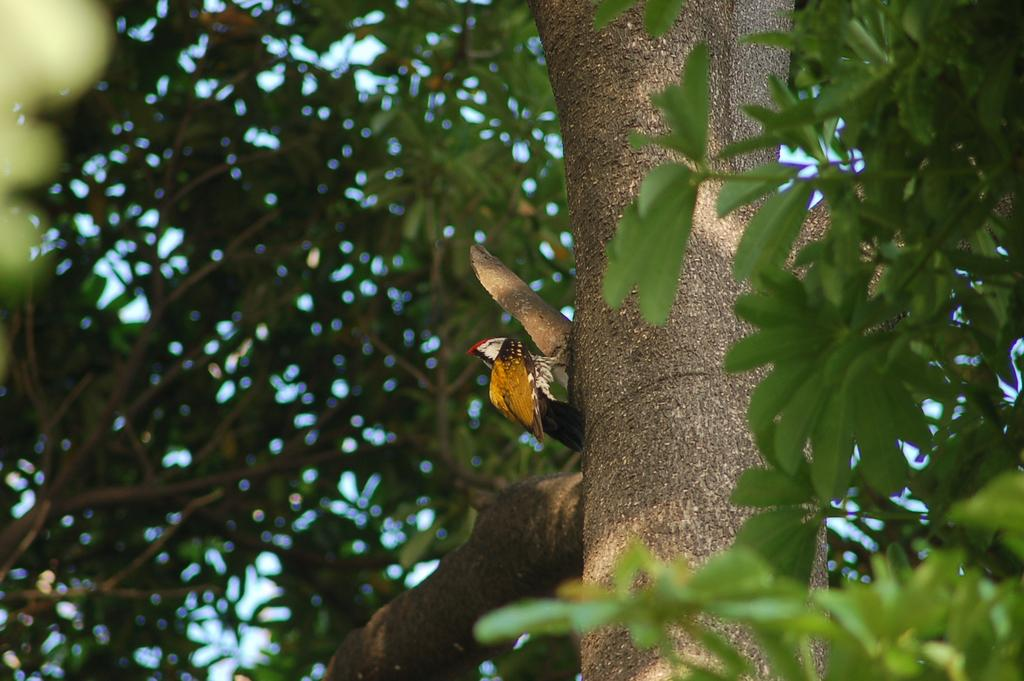What type of vegetation can be seen on the right side of the image? There are many leaves on the right side of the image. What type of tree is visible on the left side of the image? There are many branches of a tree on the left side of the image. What type of animal can be seen in the middle of the image? There is a bird in the middle of the image. What type of calendar is hanging on the tree in the image? There is no calendar present in the image; it features leaves, branches, and a bird. What type of beetle can be seen crawling on the bird in the image? There is no beetle present in the image; it only features a bird. 